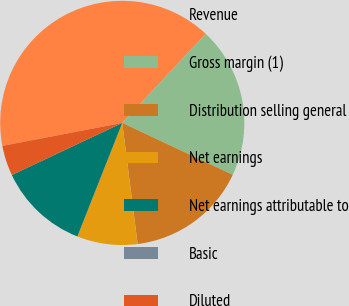<chart> <loc_0><loc_0><loc_500><loc_500><pie_chart><fcel>Revenue<fcel>Gross margin (1)<fcel>Distribution selling general<fcel>Net earnings<fcel>Net earnings attributable to<fcel>Basic<fcel>Diluted<nl><fcel>40.0%<fcel>20.0%<fcel>16.0%<fcel>8.0%<fcel>12.0%<fcel>0.0%<fcel>4.0%<nl></chart> 